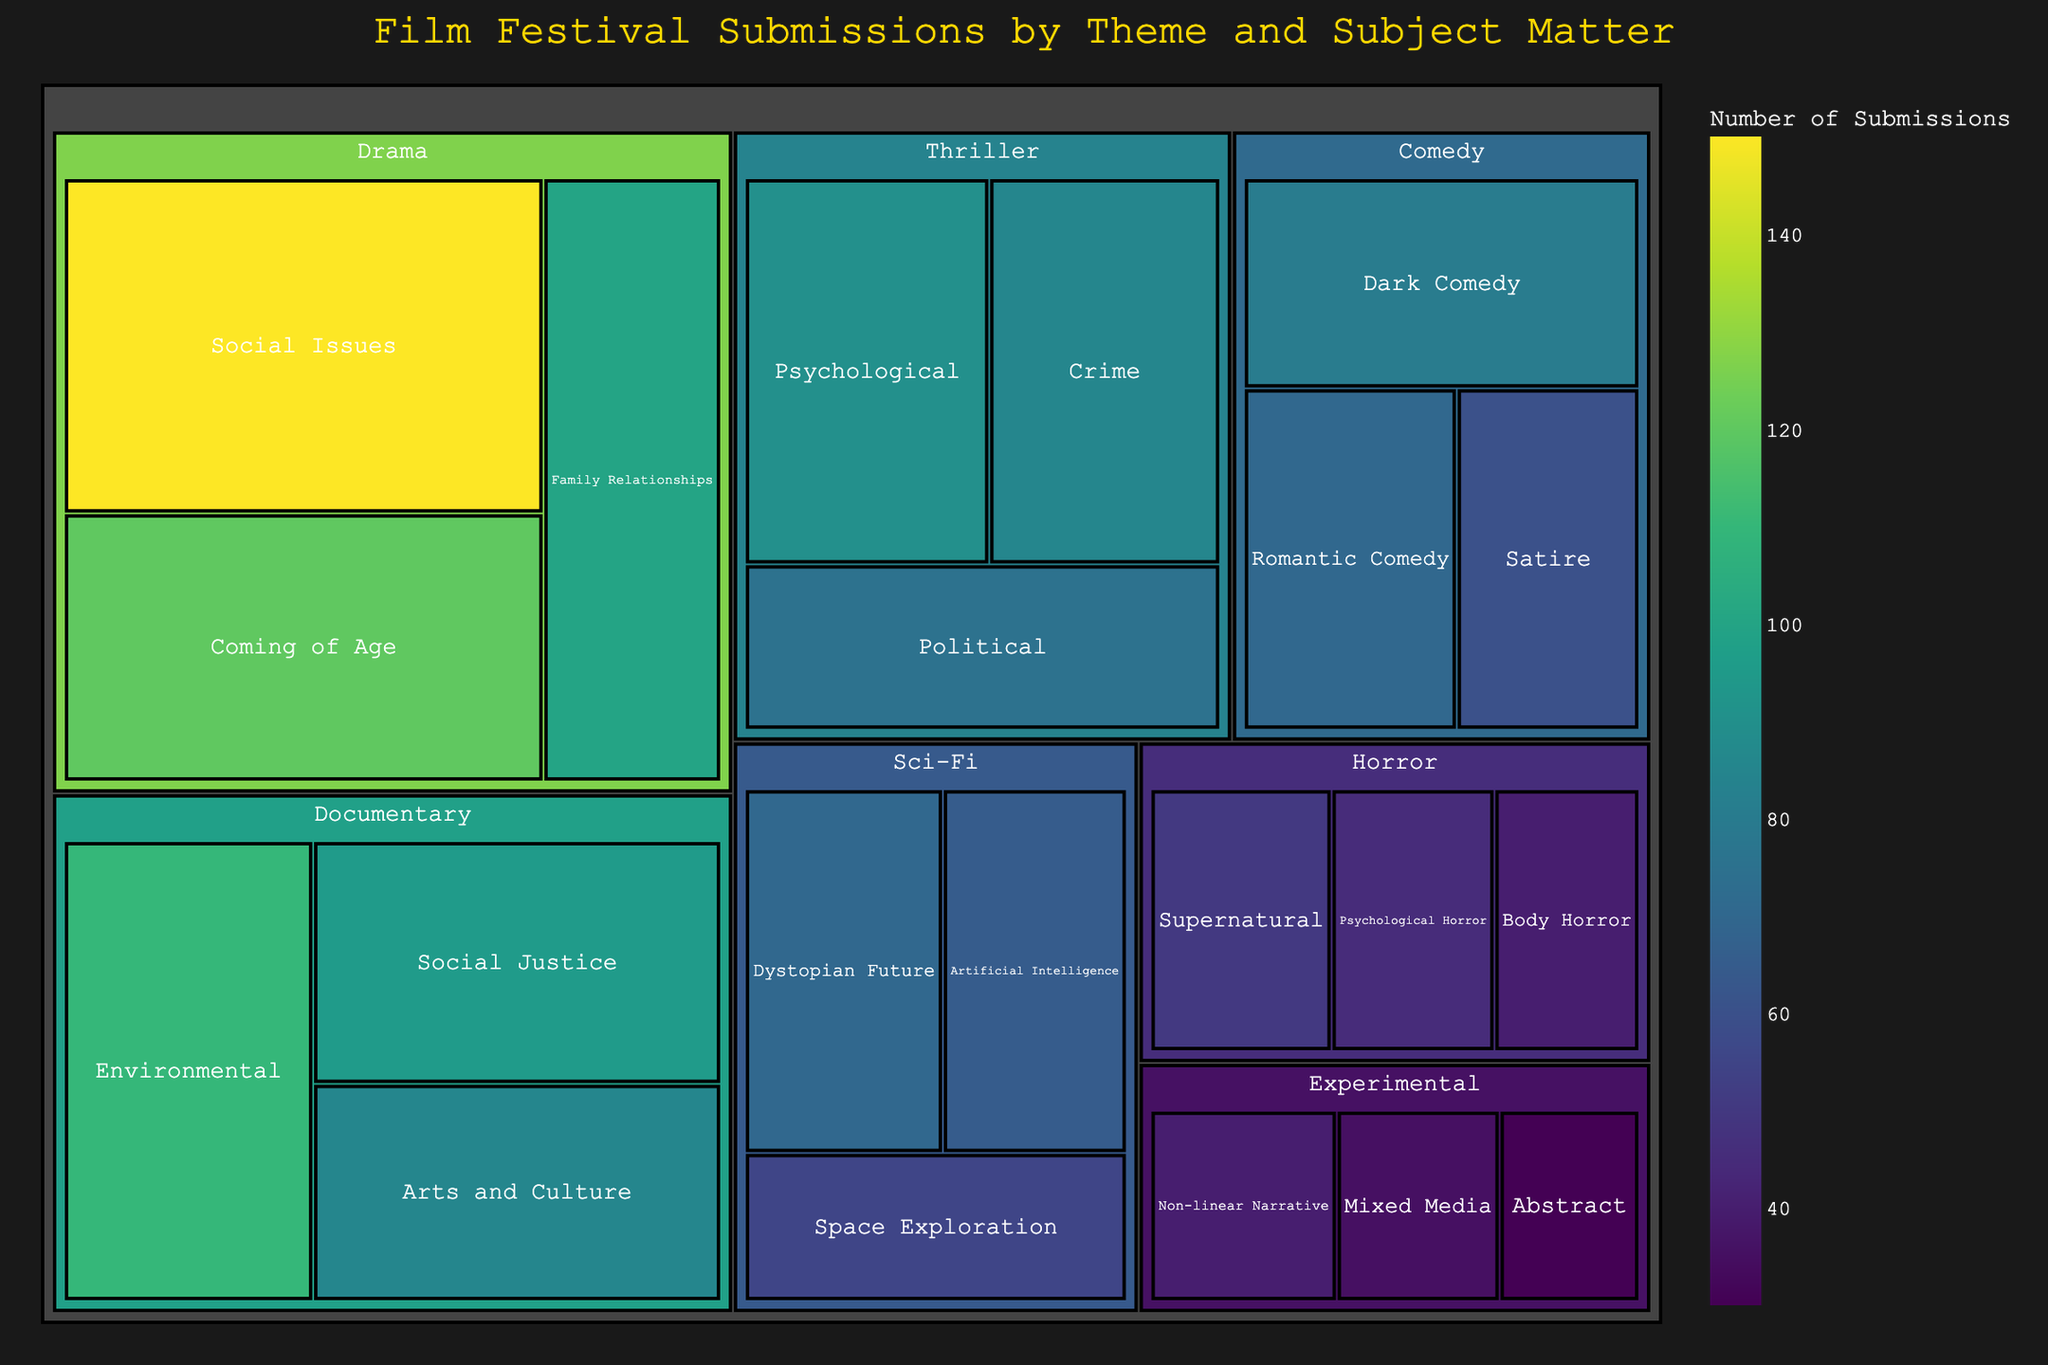What is the title of the treemap? The title is typically displayed at the top of the figure. Here, it clearly states the context of the data being visualized.
Answer: Film Festival Submissions by Theme and Subject Matter Which drama subcategory has the highest number of submissions? By examining the Drama category, the subcategory with the largest area should represent the highest number of submissions.
Answer: Social Issues How many submissions are in the Experimental category in total? Add up the values of each subcategory under Experimental. This includes Non-linear Narrative, Mixed Media, and Abstract. So, 40 + 35 + 30 = 105.
Answer: 105 Which has more submissions, Comedy or Horror? Compare the total area of the Comedy category with that of the Horror category. Comedy has 80 + 70 + 60 = 210, while Horror has 50 + 45 + 40 = 135.
Answer: Comedy What is the most popular subcategory in the Documentary category? Look for the largest block within the Documentary category. The largest block represents the subcategory with the most submissions.
Answer: Environmental Which category has the least number of submissions in a single subcategory? Identify the smallest block in the entire treemap, which represents the subcategory with the least number of submissions.
Answer: Experimental: Abstract How do the submissions in the Sci-Fi category compare to the submissions in the Thriller category? Sum the values of subcategories under Sci-Fi and compare with the sum under Thriller. Sci-Fi: 70 + 65 + 55 = 190, Thriller: 90 + 85 + 75 = 250. Thriller has more.
Answer: Thriller has more Which subcategory has the lowest number of submissions across all categories? Determine the smallest block in the entire treemap, representing the subcategory with the least value.
Answer: Experimental: Abstract What percentage of Drama submissions are focused on Coming of Age themes? Divide the Coming of Age value by the total Drama submissions and multiply by 100. Drama total is 150 + 120 + 100 = 370, Coming of Age is 120. (120 / 370) * 100 ≈ 32.43%.
Answer: ~32.43% How do the submissions in Psychological themes (Horror and Thriller combined) compare to the Comedy genre? Sum Psychological Horror (Horror) and Psychological (Thriller) then compare with total Comedy. Psychological: 45 + 90 = 135, Comedy: 80 + 70 + 60 = 210.
Answer: Comedy has more 